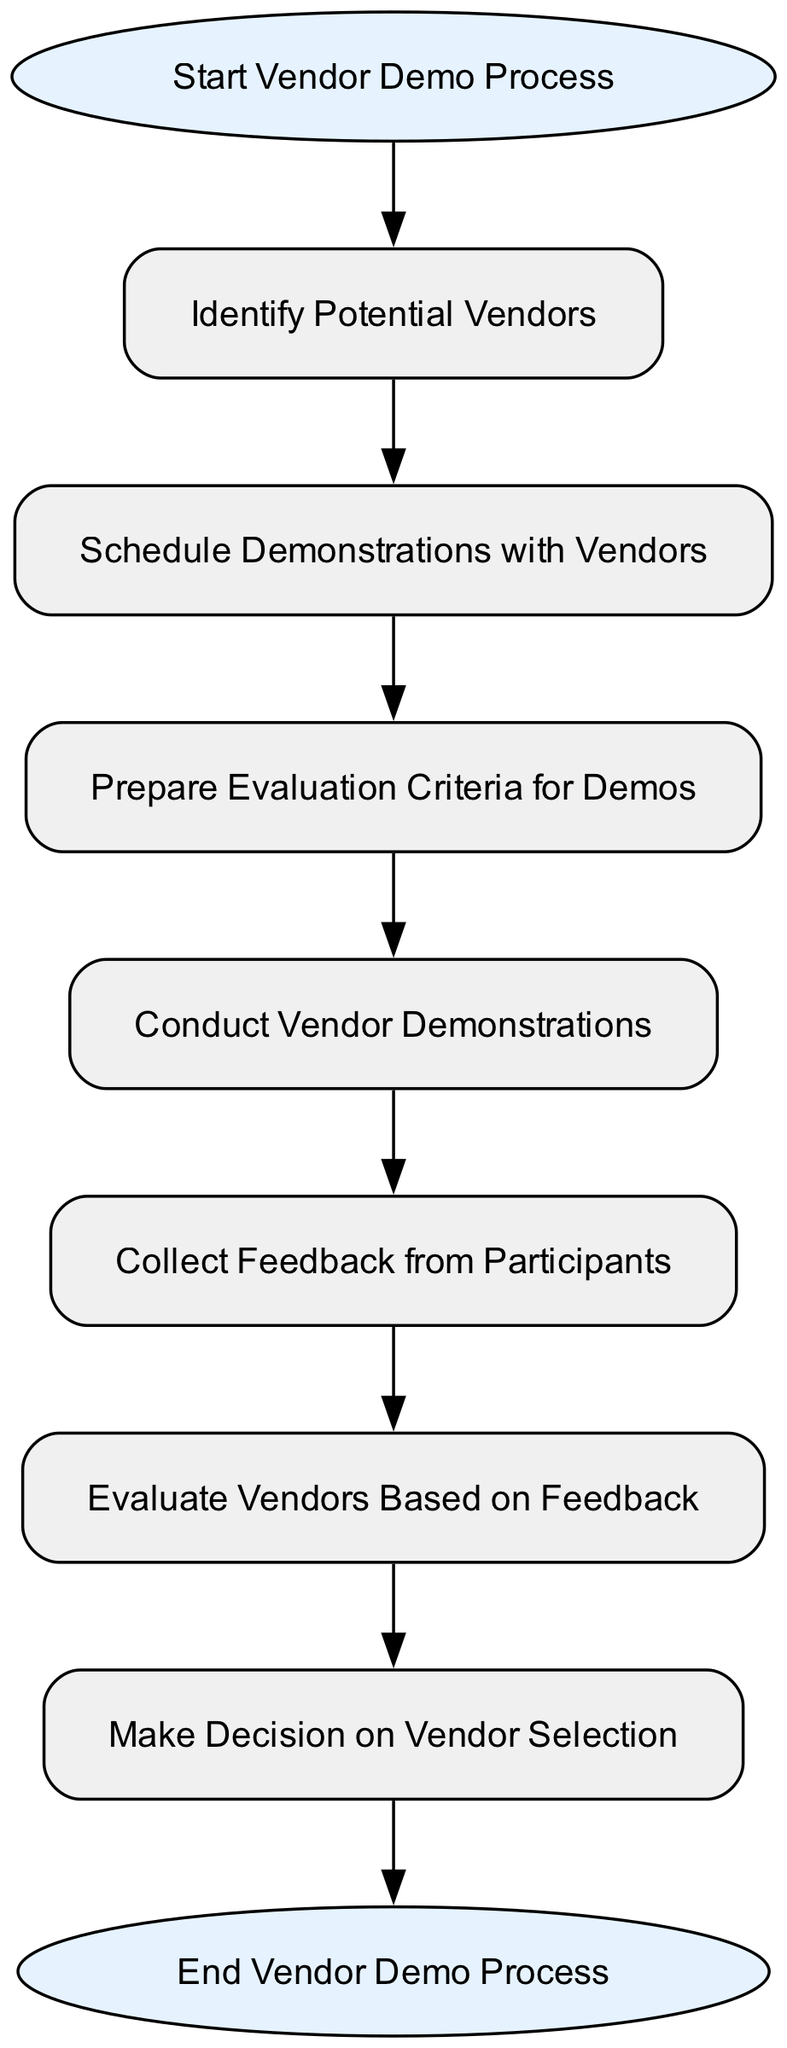What is the first step in the vendor demo process? The diagram shows that the first step, or starting point, is labeled as "Start Vendor Demo Process." This is the entry point before any other actions take place.
Answer: Start Vendor Demo Process How many nodes are present in the diagram? By counting the elements in the diagram, there are a total of 9 nodes representing different steps in the vendor demo process.
Answer: 9 What node comes after "Conduct Vendor Demonstrations"? The flow indicates that after "Conduct Vendor Demonstrations," the next step is to "Collect Feedback from Participants." This is the direct continuation of the process from one step to another.
Answer: Collect Feedback from Participants Which nodes are related by a direct connection from "Evaluate Vendors"? The node "Evaluate Vendors" is directly connected to "Make Decision on Vendor Selection," indicating that these two steps are sequential in the process. Therefore, they share a direct relationship.
Answer: Make Decision on Vendor Selection What is the last step in the vendor demo process? The diagram shows that the final step, or endpoint, is labeled as "End Vendor Demo Process," indicating the conclusion of the entire workflow.
Answer: End Vendor Demo Process How many connections are there between the nodes? By counting the directional connections between nodes, we see that there are a total of 8 connections that link the various steps in the vendor demo workflow.
Answer: 8 What is the relationship between "Prepare Evaluation Criteria" and "Conduct Vendor Demonstrations"? The relationship is sequential; "Prepare Evaluation Criteria" directly leads into "Conduct Vendor Demonstrations," meaning you first prepare the criteria and then proceed to the actual demonstrations based on that preparation.
Answer: Sequential Which steps must be completed before making a decision? Before making a decision on vendor selection, it is necessary to complete the steps: "Collect Feedback from Participants" and "Evaluate Vendors Based on Feedback," which must be addressed to arrive at a decision.
Answer: Collect Feedback from Participants, Evaluate Vendors Based on Feedback What shape is used for the start and end nodes in the diagram? The start and end nodes are represented in an oval shape, distinguishing them from other steps which are shown as rectangles.
Answer: Oval 